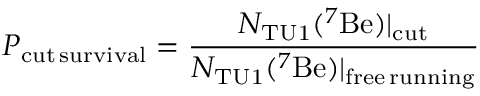Convert formula to latex. <formula><loc_0><loc_0><loc_500><loc_500>P _ { c u t \, s u r v i v a l } = \frac { N _ { T U 1 } ( ^ { 7 } B e ) | _ { c u t } } { N _ { T U 1 } ( ^ { 7 } B e ) | _ { f r e e \, r u n n i n g } }</formula> 